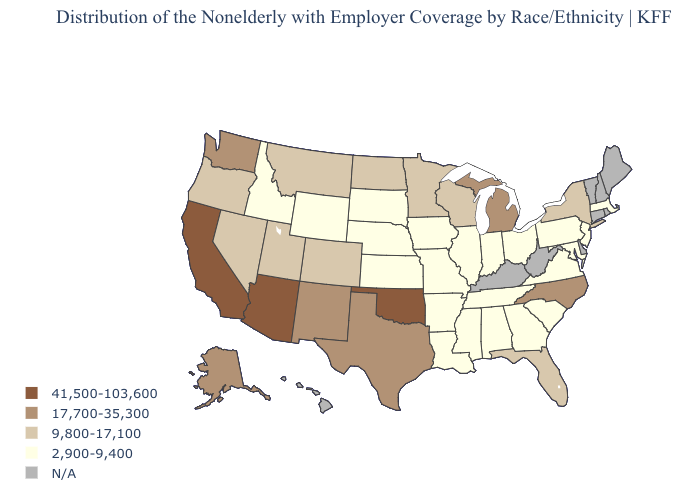Among the states that border Alabama , which have the highest value?
Short answer required. Florida. Name the states that have a value in the range N/A?
Concise answer only. Connecticut, Delaware, Hawaii, Kentucky, Maine, New Hampshire, Rhode Island, Vermont, West Virginia. Name the states that have a value in the range 2,900-9,400?
Concise answer only. Alabama, Arkansas, Georgia, Idaho, Illinois, Indiana, Iowa, Kansas, Louisiana, Maryland, Massachusetts, Mississippi, Missouri, Nebraska, New Jersey, Ohio, Pennsylvania, South Carolina, South Dakota, Tennessee, Virginia, Wyoming. Does the first symbol in the legend represent the smallest category?
Keep it brief. No. Does the map have missing data?
Quick response, please. Yes. What is the lowest value in states that border Wyoming?
Be succinct. 2,900-9,400. What is the value of Iowa?
Write a very short answer. 2,900-9,400. What is the lowest value in the West?
Answer briefly. 2,900-9,400. Does the map have missing data?
Concise answer only. Yes. Among the states that border Nebraska , which have the lowest value?
Write a very short answer. Iowa, Kansas, Missouri, South Dakota, Wyoming. What is the highest value in the USA?
Concise answer only. 41,500-103,600. What is the value of Indiana?
Answer briefly. 2,900-9,400. What is the highest value in the Northeast ?
Give a very brief answer. 9,800-17,100. Name the states that have a value in the range 2,900-9,400?
Be succinct. Alabama, Arkansas, Georgia, Idaho, Illinois, Indiana, Iowa, Kansas, Louisiana, Maryland, Massachusetts, Mississippi, Missouri, Nebraska, New Jersey, Ohio, Pennsylvania, South Carolina, South Dakota, Tennessee, Virginia, Wyoming. 